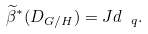Convert formula to latex. <formula><loc_0><loc_0><loc_500><loc_500>\widetilde { \beta } ^ { * } ( D _ { G / H } ) = J d _ { \ q } .</formula> 